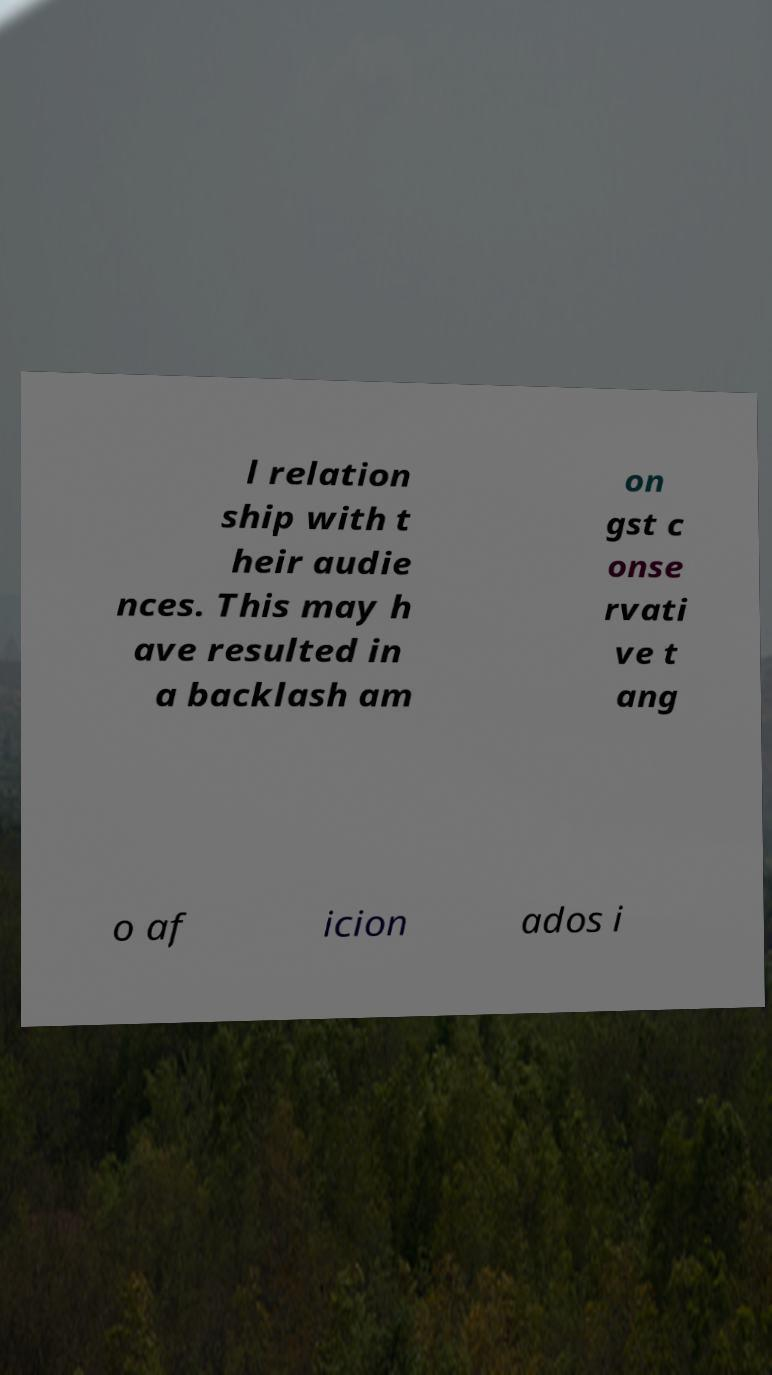Can you accurately transcribe the text from the provided image for me? l relation ship with t heir audie nces. This may h ave resulted in a backlash am on gst c onse rvati ve t ang o af icion ados i 